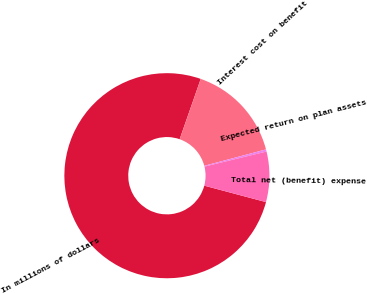<chart> <loc_0><loc_0><loc_500><loc_500><pie_chart><fcel>In millions of dollars<fcel>Interest cost on benefit<fcel>Expected return on plan assets<fcel>Total net (benefit) expense<nl><fcel>76.22%<fcel>15.52%<fcel>0.34%<fcel>7.93%<nl></chart> 